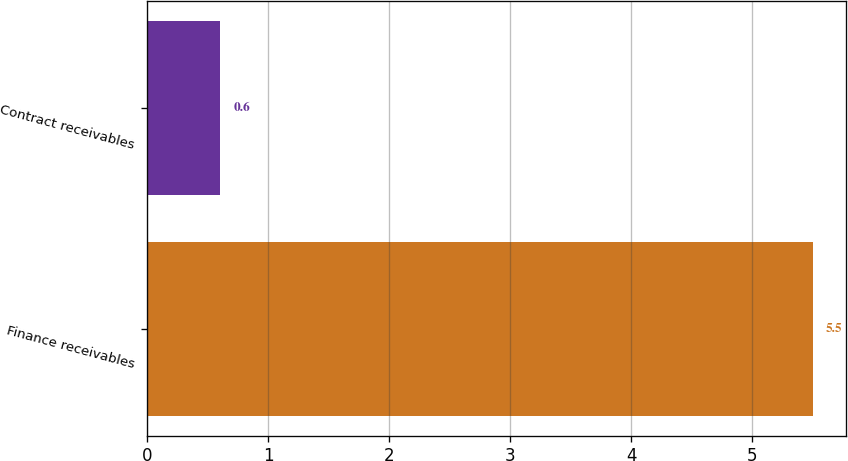Convert chart to OTSL. <chart><loc_0><loc_0><loc_500><loc_500><bar_chart><fcel>Finance receivables<fcel>Contract receivables<nl><fcel>5.5<fcel>0.6<nl></chart> 